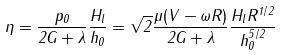Convert formula to latex. <formula><loc_0><loc_0><loc_500><loc_500>\eta = \frac { p _ { 0 } } { 2 G + \lambda } \frac { H _ { l } } { h _ { 0 } } = \sqrt { 2 } \frac { \mu ( V - \omega R ) } { 2 G + \lambda } \frac { H _ { l } R ^ { 1 / 2 } } { h _ { 0 } ^ { 5 / 2 } }</formula> 